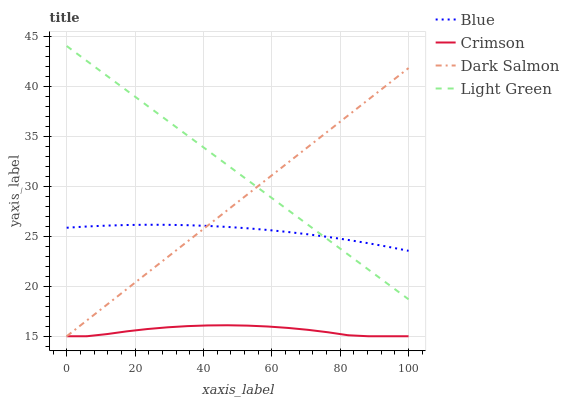Does Dark Salmon have the minimum area under the curve?
Answer yes or no. No. Does Dark Salmon have the maximum area under the curve?
Answer yes or no. No. Is Dark Salmon the smoothest?
Answer yes or no. No. Is Dark Salmon the roughest?
Answer yes or no. No. Does Light Green have the lowest value?
Answer yes or no. No. Does Dark Salmon have the highest value?
Answer yes or no. No. Is Crimson less than Blue?
Answer yes or no. Yes. Is Light Green greater than Crimson?
Answer yes or no. Yes. Does Crimson intersect Blue?
Answer yes or no. No. 